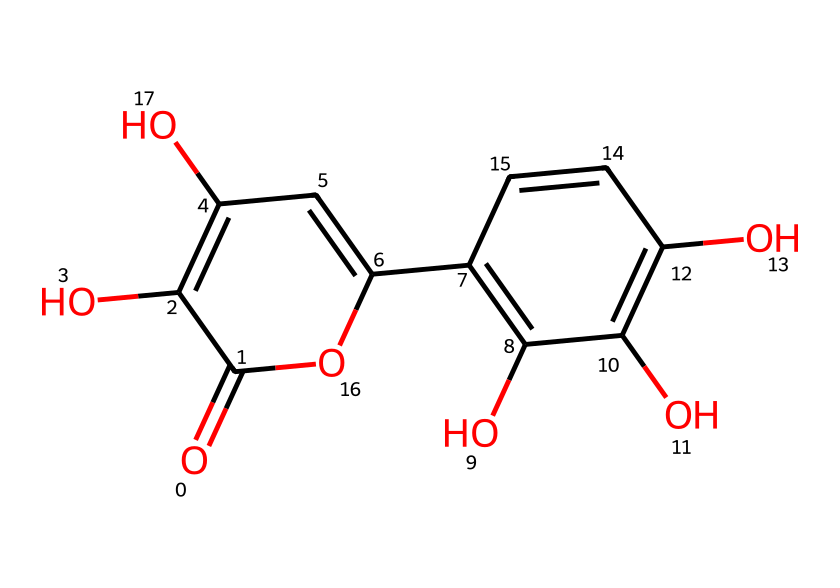What is the molecular formula for quercetin? The molecular formula can be derived by counting the number of each type of atom represented in the SMILES notation. In this case, there are 15 carbon atoms, 10 hydrogen atoms, and 7 oxygen atoms, leading to the formula C15H10O7.
Answer: C15H10O7 How many hydroxyl (–OH) groups are present in quercetin? In the given SMILES representation, hydroxyl groups are indicated by 'O' connected to a carbon atom. Counting these, there are five –OH groups represented in the structure.
Answer: 5 What type of chemical structure does quercetin represent? Quercetin is categorized as a flavonoid due to its specific structure characterized by multiple aromatic rings and hydroxyl groups.
Answer: flavonoid What is the boiling point range of quercetin? Quercetin generally has a boiling point around 250-370 degrees Celsius, indicating its stability at higher temperatures. This information can be corroborated with literature sources regarding its physical properties.
Answer: 250-370 degrees Celsius How does the presence of multiple hydroxyl groups affect the properties of quercetin? The multiple hydroxyl groups in quercetin enhance its antioxidant properties due to their ability to donate hydrogen atoms, which helps neutralize free radicals. This is crucial in understanding the functional role of quercetin in biological systems.
Answer: antioxidant properties How many pi bonds are present in the quercetin structure? In the SMILES representation, pi bonds are usually indicated by double bonds. Counting the double bonds in the structure reveals that there are six pi bonds present in quercetin.
Answer: 6 